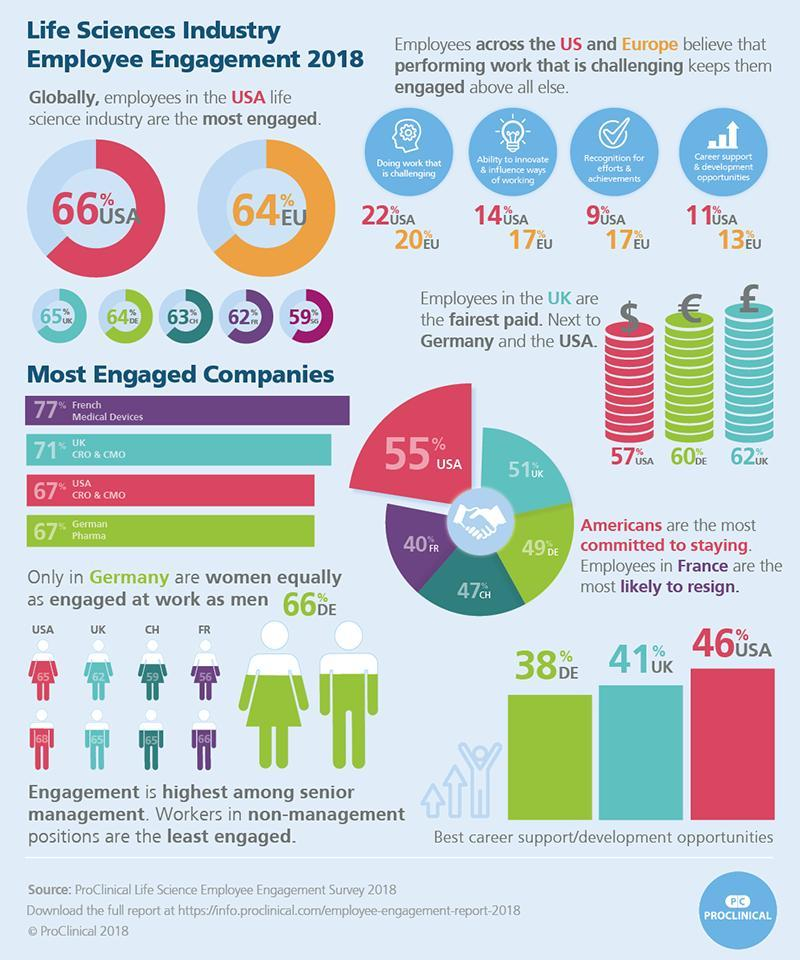What percentage of women are engaged at work in UK in 2018?
Answer the question with a short phrase. 62 What percentage of women are engaged at work in Switzerland in 2018? 59 What percentage of best career support/development opportunities were found in Germany in 2018? 38% What percentage of best career support/development opportunities were found in UK in 2018? 41% What percentage of employees across Europe got recognition for efforts & achievements in 2018? 17% What percentage of employees across Europe are doing work that is challenging in 2018? 20% What percentage of men are engaged at work in USA in 2018? 68 What percentage of men are engaged at work in France in 2018? 66 